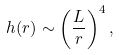Convert formula to latex. <formula><loc_0><loc_0><loc_500><loc_500>h ( r ) \sim \left ( \frac { L } { r } \right ) ^ { 4 } ,</formula> 